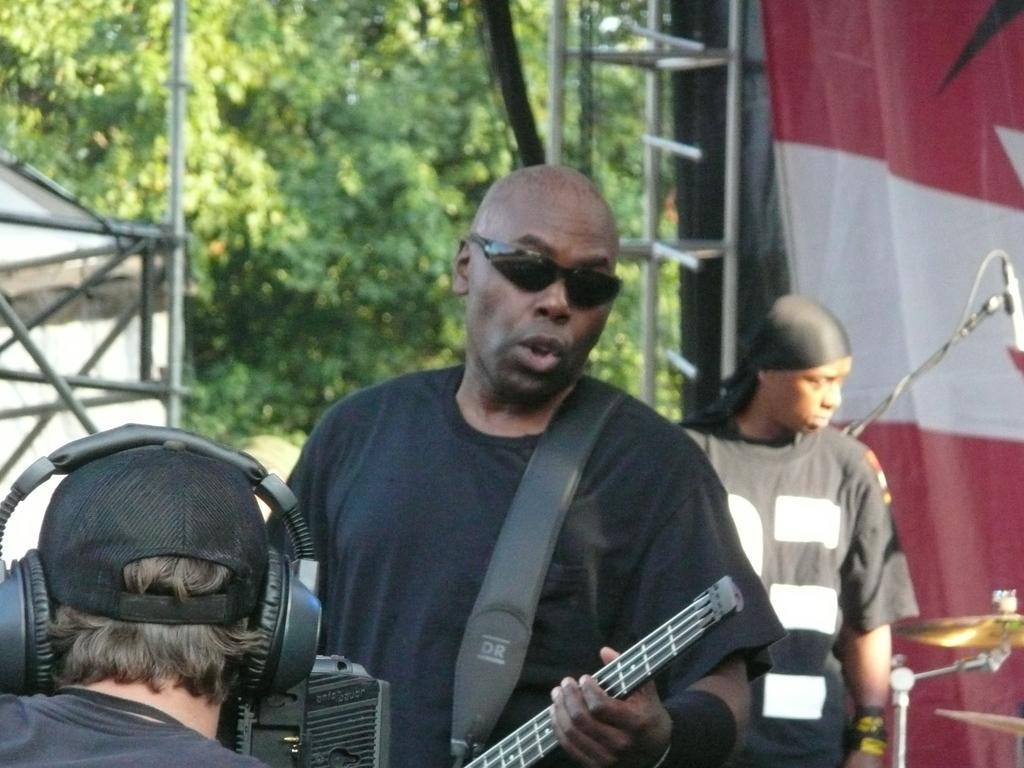How would you summarize this image in a sentence or two? In this picture we can see three persons. He has goggles and he is playing guitar. On the background there are trees. And this is the cloth. 